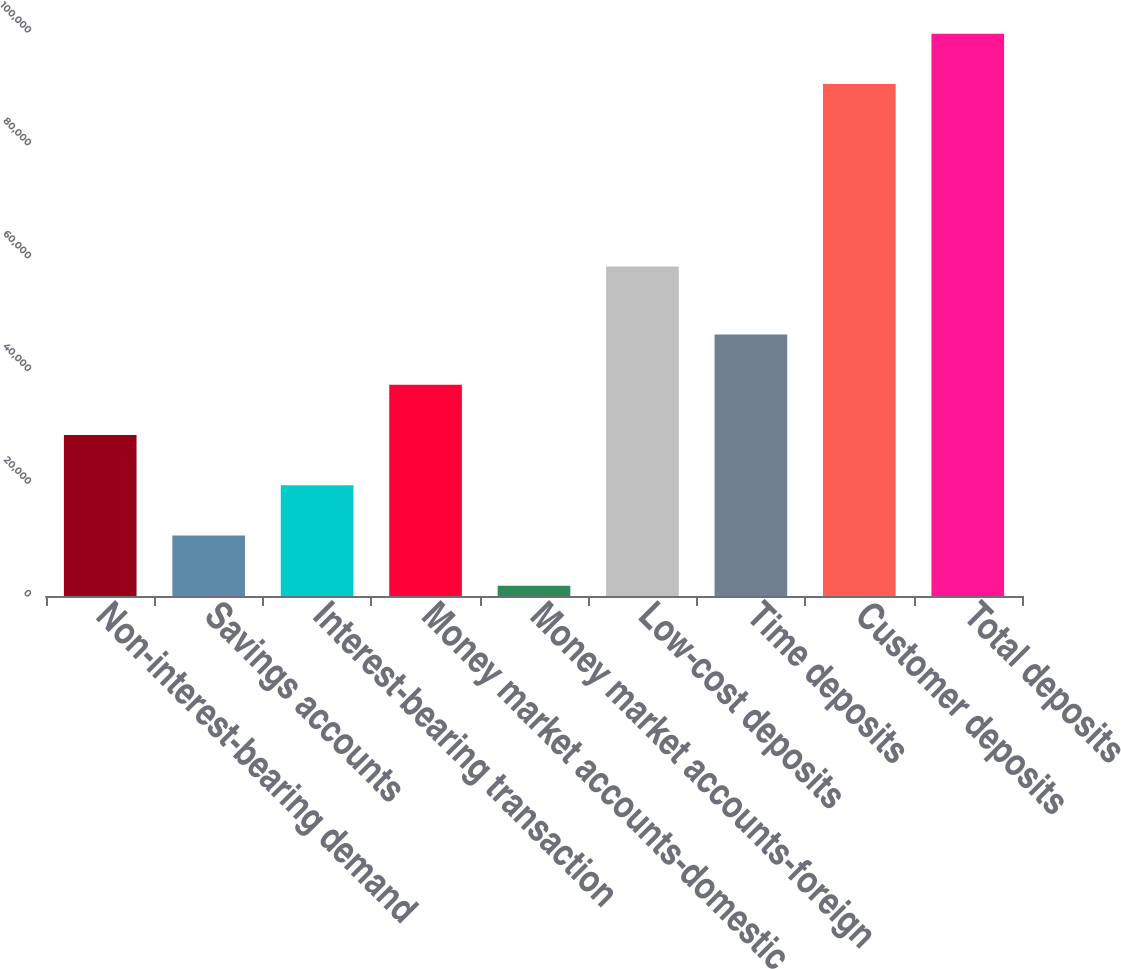<chart> <loc_0><loc_0><loc_500><loc_500><bar_chart><fcel>Non-interest-bearing demand<fcel>Savings accounts<fcel>Interest-bearing transaction<fcel>Money market accounts-domestic<fcel>Money market accounts-foreign<fcel>Low-cost deposits<fcel>Time deposits<fcel>Customer deposits<fcel>Total deposits<nl><fcel>28539.6<fcel>10721.2<fcel>19630.4<fcel>37448.8<fcel>1812<fcel>58425<fcel>46358<fcel>90794<fcel>99703.2<nl></chart> 